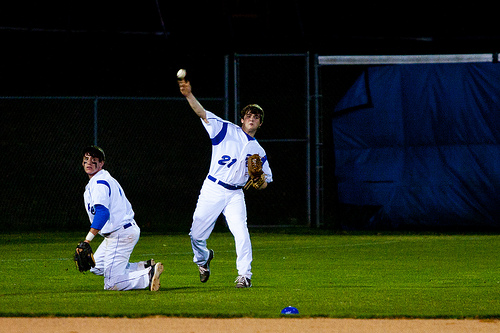What part of the baseball game might this be? Given the focused posture of the players, this appears to be in the middle of a pitch, a critical and recurring component of a baseball game. It could be any inning where the pitcher is tasked with getting the ball past the batter. 